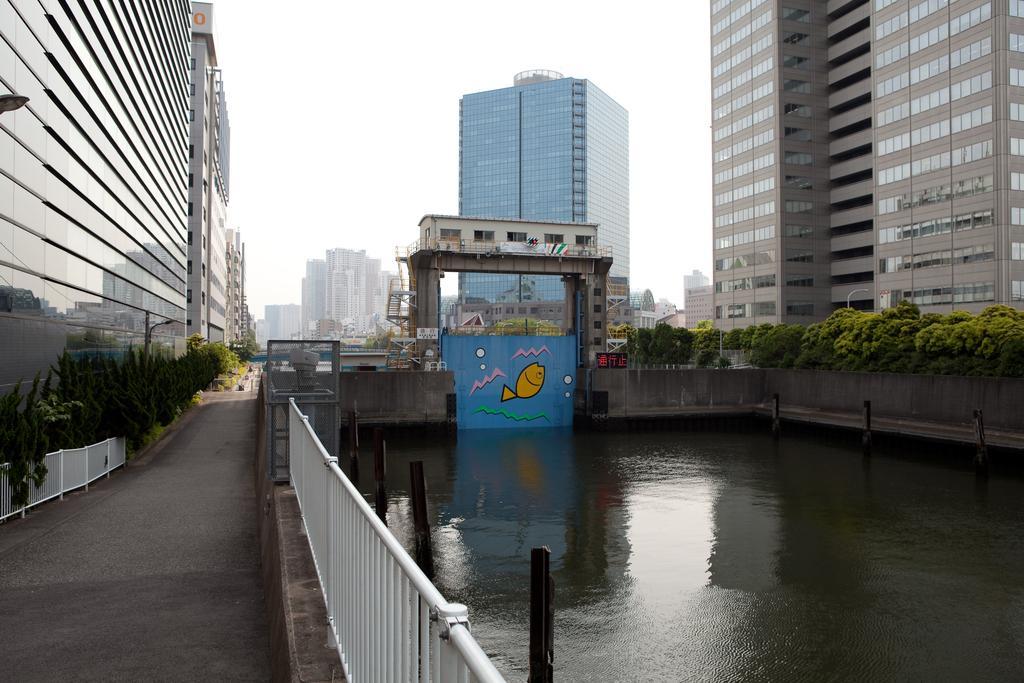Describe this image in one or two sentences. In this image I can see trees, buildings, plants, fence, poles and the water. In the background I can see the sky. 